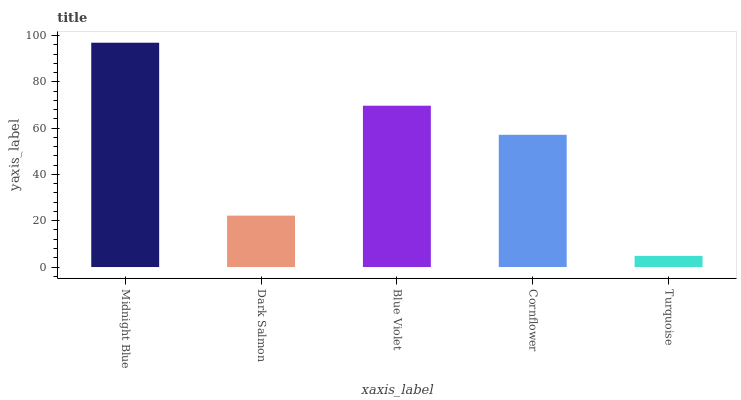Is Turquoise the minimum?
Answer yes or no. Yes. Is Midnight Blue the maximum?
Answer yes or no. Yes. Is Dark Salmon the minimum?
Answer yes or no. No. Is Dark Salmon the maximum?
Answer yes or no. No. Is Midnight Blue greater than Dark Salmon?
Answer yes or no. Yes. Is Dark Salmon less than Midnight Blue?
Answer yes or no. Yes. Is Dark Salmon greater than Midnight Blue?
Answer yes or no. No. Is Midnight Blue less than Dark Salmon?
Answer yes or no. No. Is Cornflower the high median?
Answer yes or no. Yes. Is Cornflower the low median?
Answer yes or no. Yes. Is Blue Violet the high median?
Answer yes or no. No. Is Midnight Blue the low median?
Answer yes or no. No. 